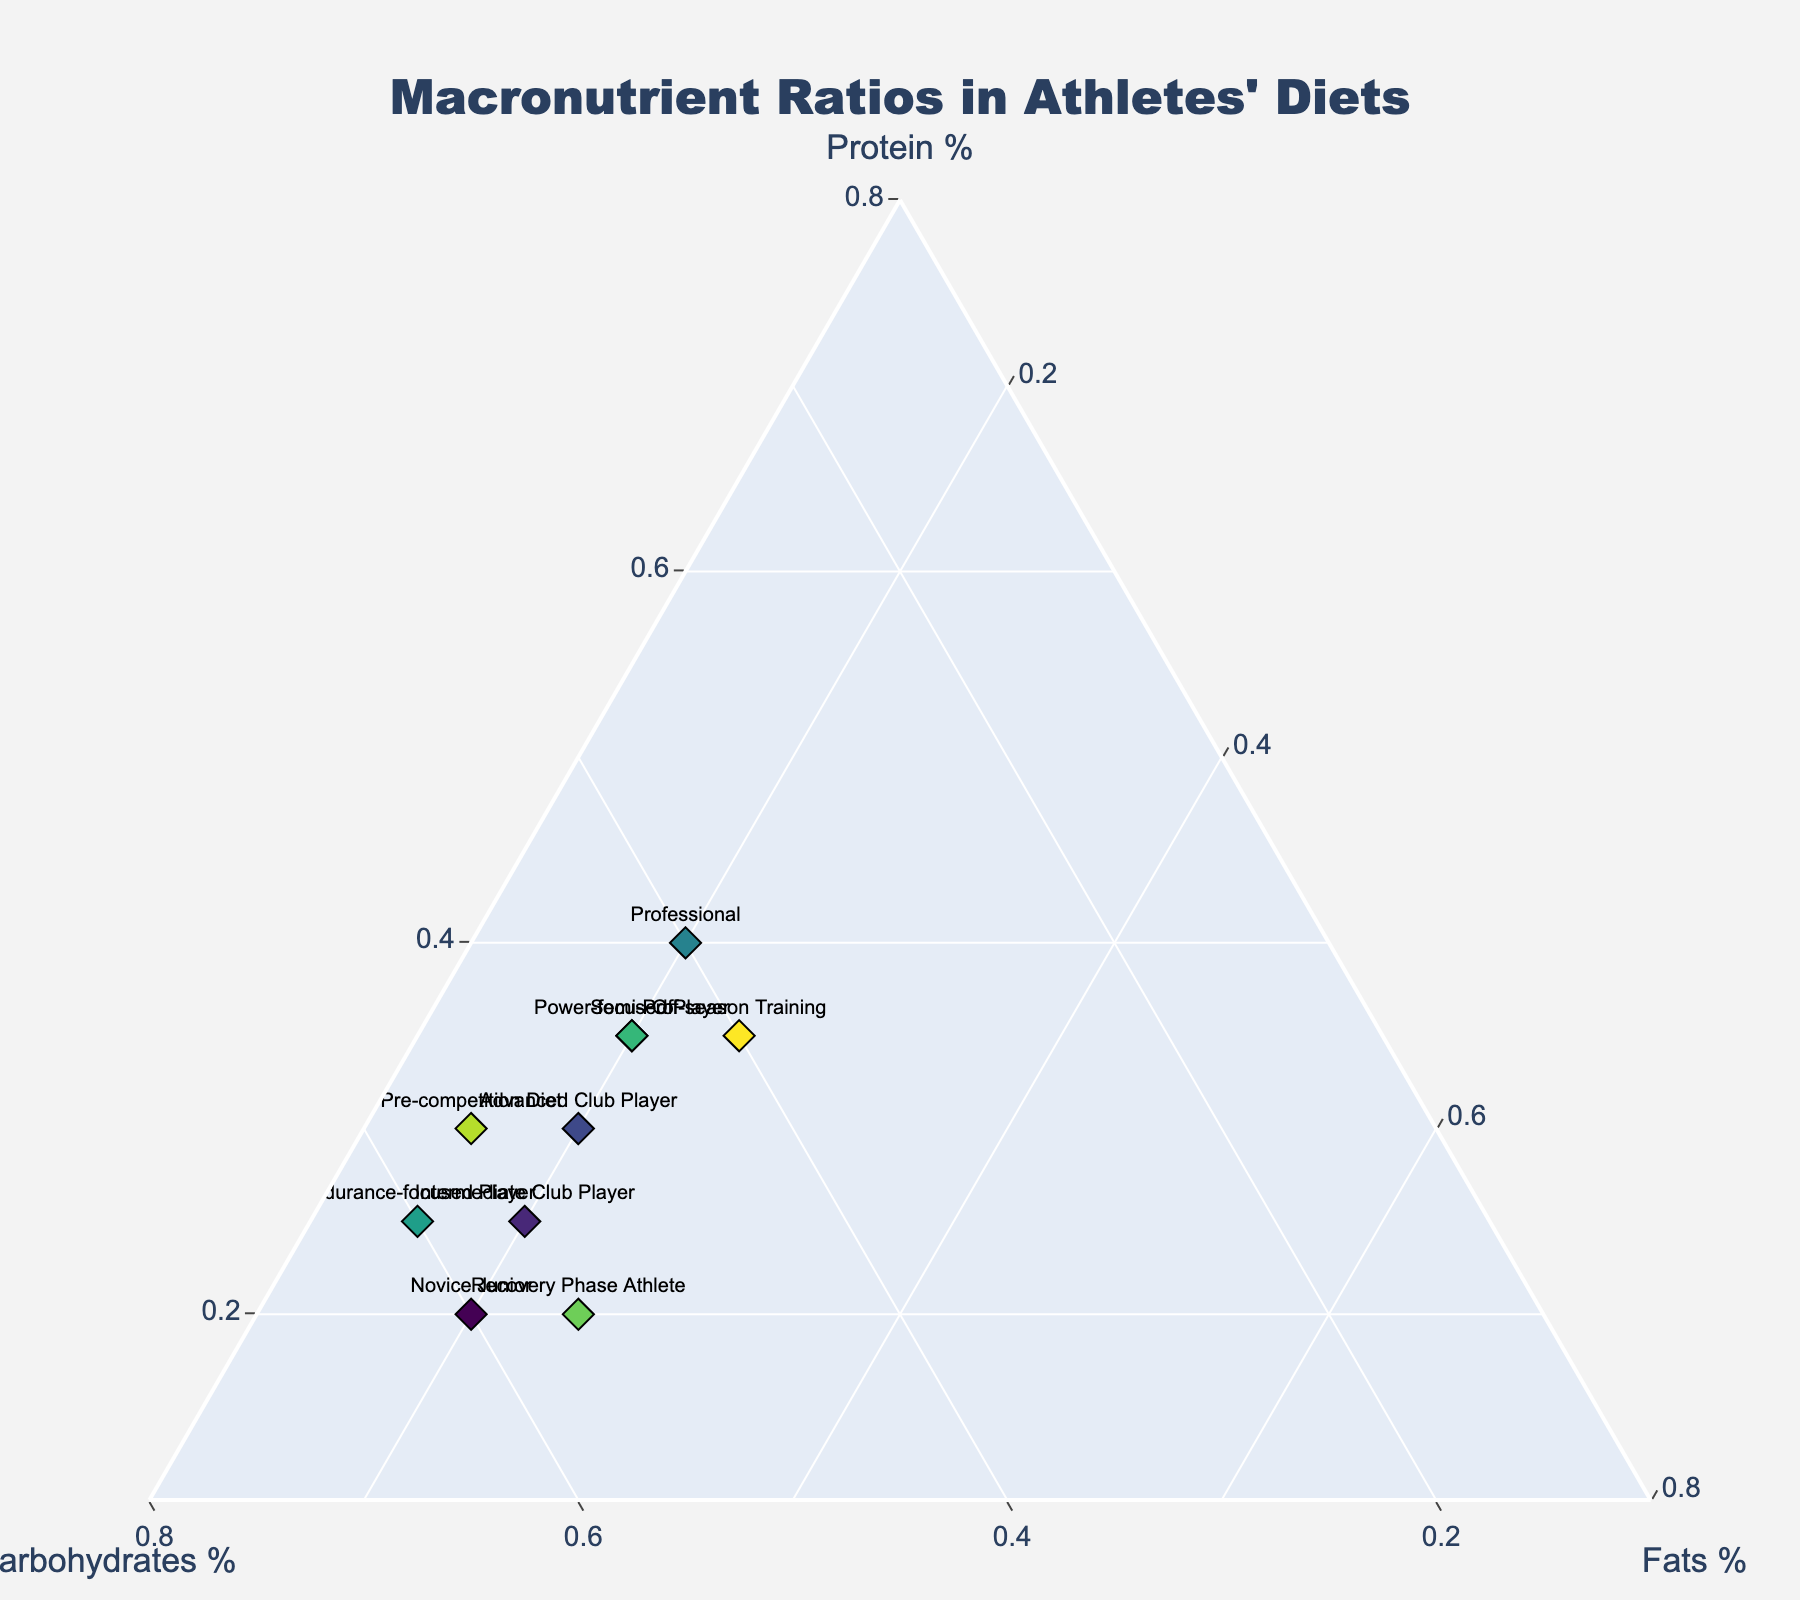What is the title of the figure? The title is typically found at the top of the figure and often in a larger or bold font to distinguish it from other text.
Answer: Macronutrient Ratios in Athletes' Diets How many distinct athlete categories are represented in the plot? One way to determine this is by counting the number of different text labels (athlete categories) present in the plot.
Answer: 10 What is the macronutrient ratio for a Semi-Pro athlete? Look for the corresponding point labeled "Semi-Pro" and read the percentage values for Protein, Carbohydrates, and Fats.
Answer: 35% Protein, 45% Carbohydrates, 20% Fats Which athlete category has the highest protein percentage? Identify the data points and compare the 'Protein' values, noting which category has the highest percentage.
Answer: Professional How does the macronutrient composition of a Recovery Phase Athlete compare to a Novice Junior? Compare the values for Protein, Carbohydrates, and Fats between the two categories.
Answer: Recovery Phase Athlete: 20% Protein, 55% Carbohydrates, 25% Fats; Novice Junior: 20% Protein, 60% Carbohydrates, 20% Fats Which athlete category has the least percentage of fats? Identify and compare the 'Fats' values across all data points to find the lowest value.
Answer: Endurance-focused Player What is the predominant macronutrient in the diet of an Intermediate Club Player and an Advanced Club Player? For each category, identify which macronutrient has the highest percentage.
Answer: Carbohydrates for both Between an Endurance-focused Player and a Power-focused Player, who has a higher carbohydrate ratio? Compare the 'Carbohydrates' percentages of the two athlete categories.
Answer: Endurance-focused Player Estimate the average protein percentage for all athlete categories. Sum all the protein percentages and divide by the number of athlete categories. Explanation: (20 + 25 + 30 + 35 + 40 + 25 + 35 + 20 + 30 + 35) / 10 = 29
Answer: 29% What changes in macronutrient composition can be observed from a Pre-competition Diet to Off-season Training? Compare the macronutrient percentages of these two categories, focusing on the differences.
Answer: Protein increases from 30% to 35%, Carbohydrates decrease from 55% to 40%, and Fats increase from 15% to 25% 